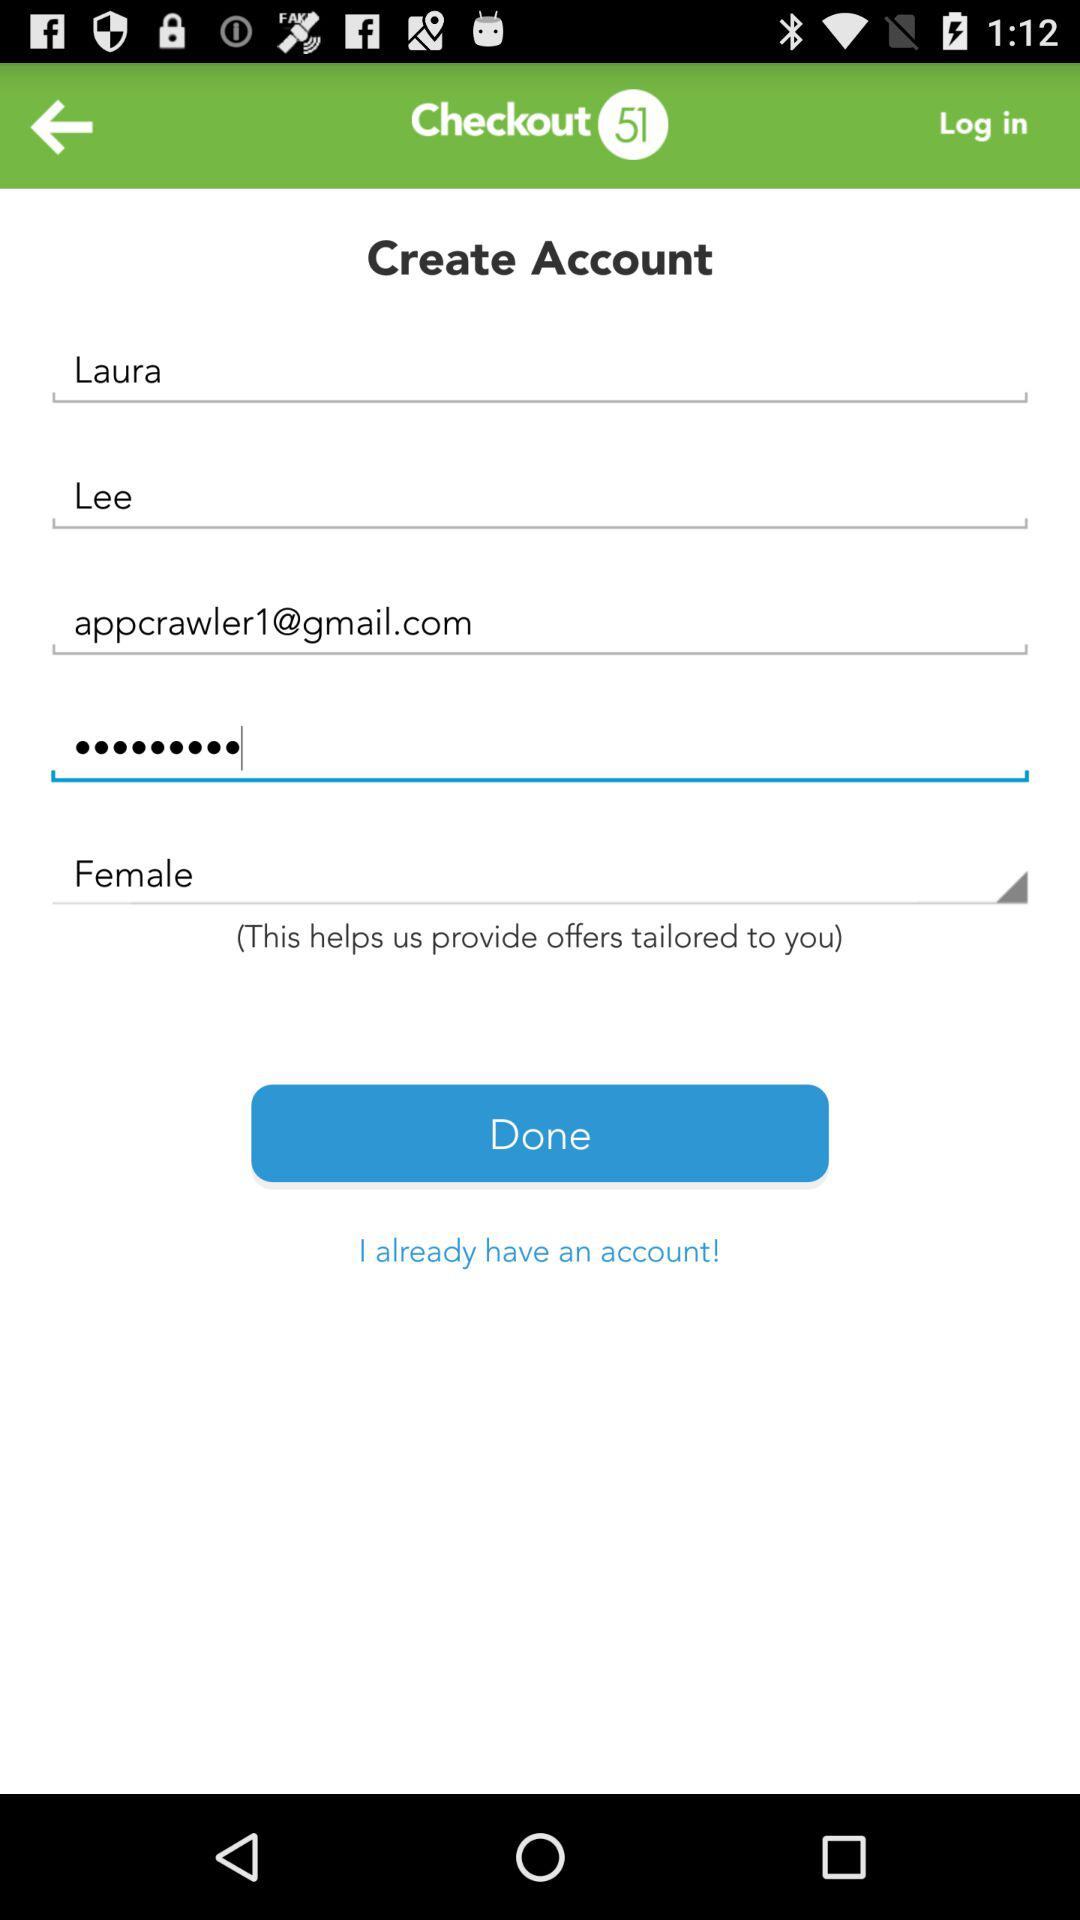How many text inputs have an email address as their value?
Answer the question using a single word or phrase. 1 